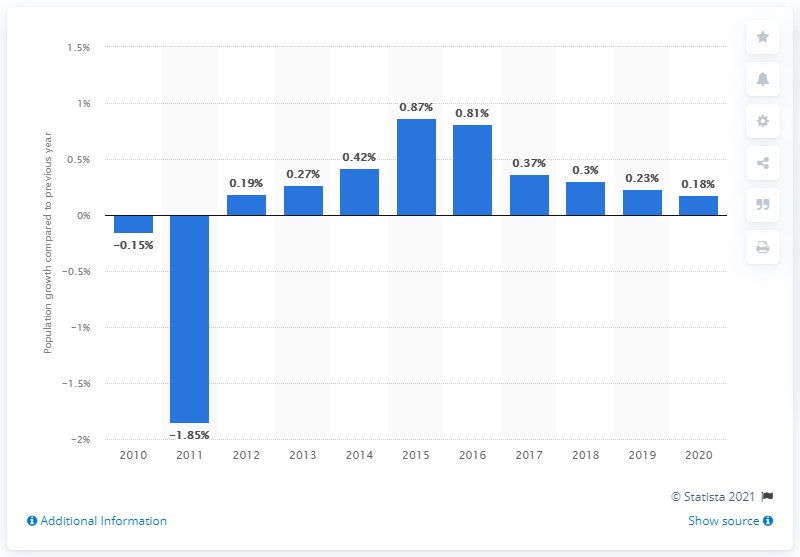Mention a couple of crucial points in this snapshot. According to the latest available data, Germany's population increased by 0.18% in the year 2020. 